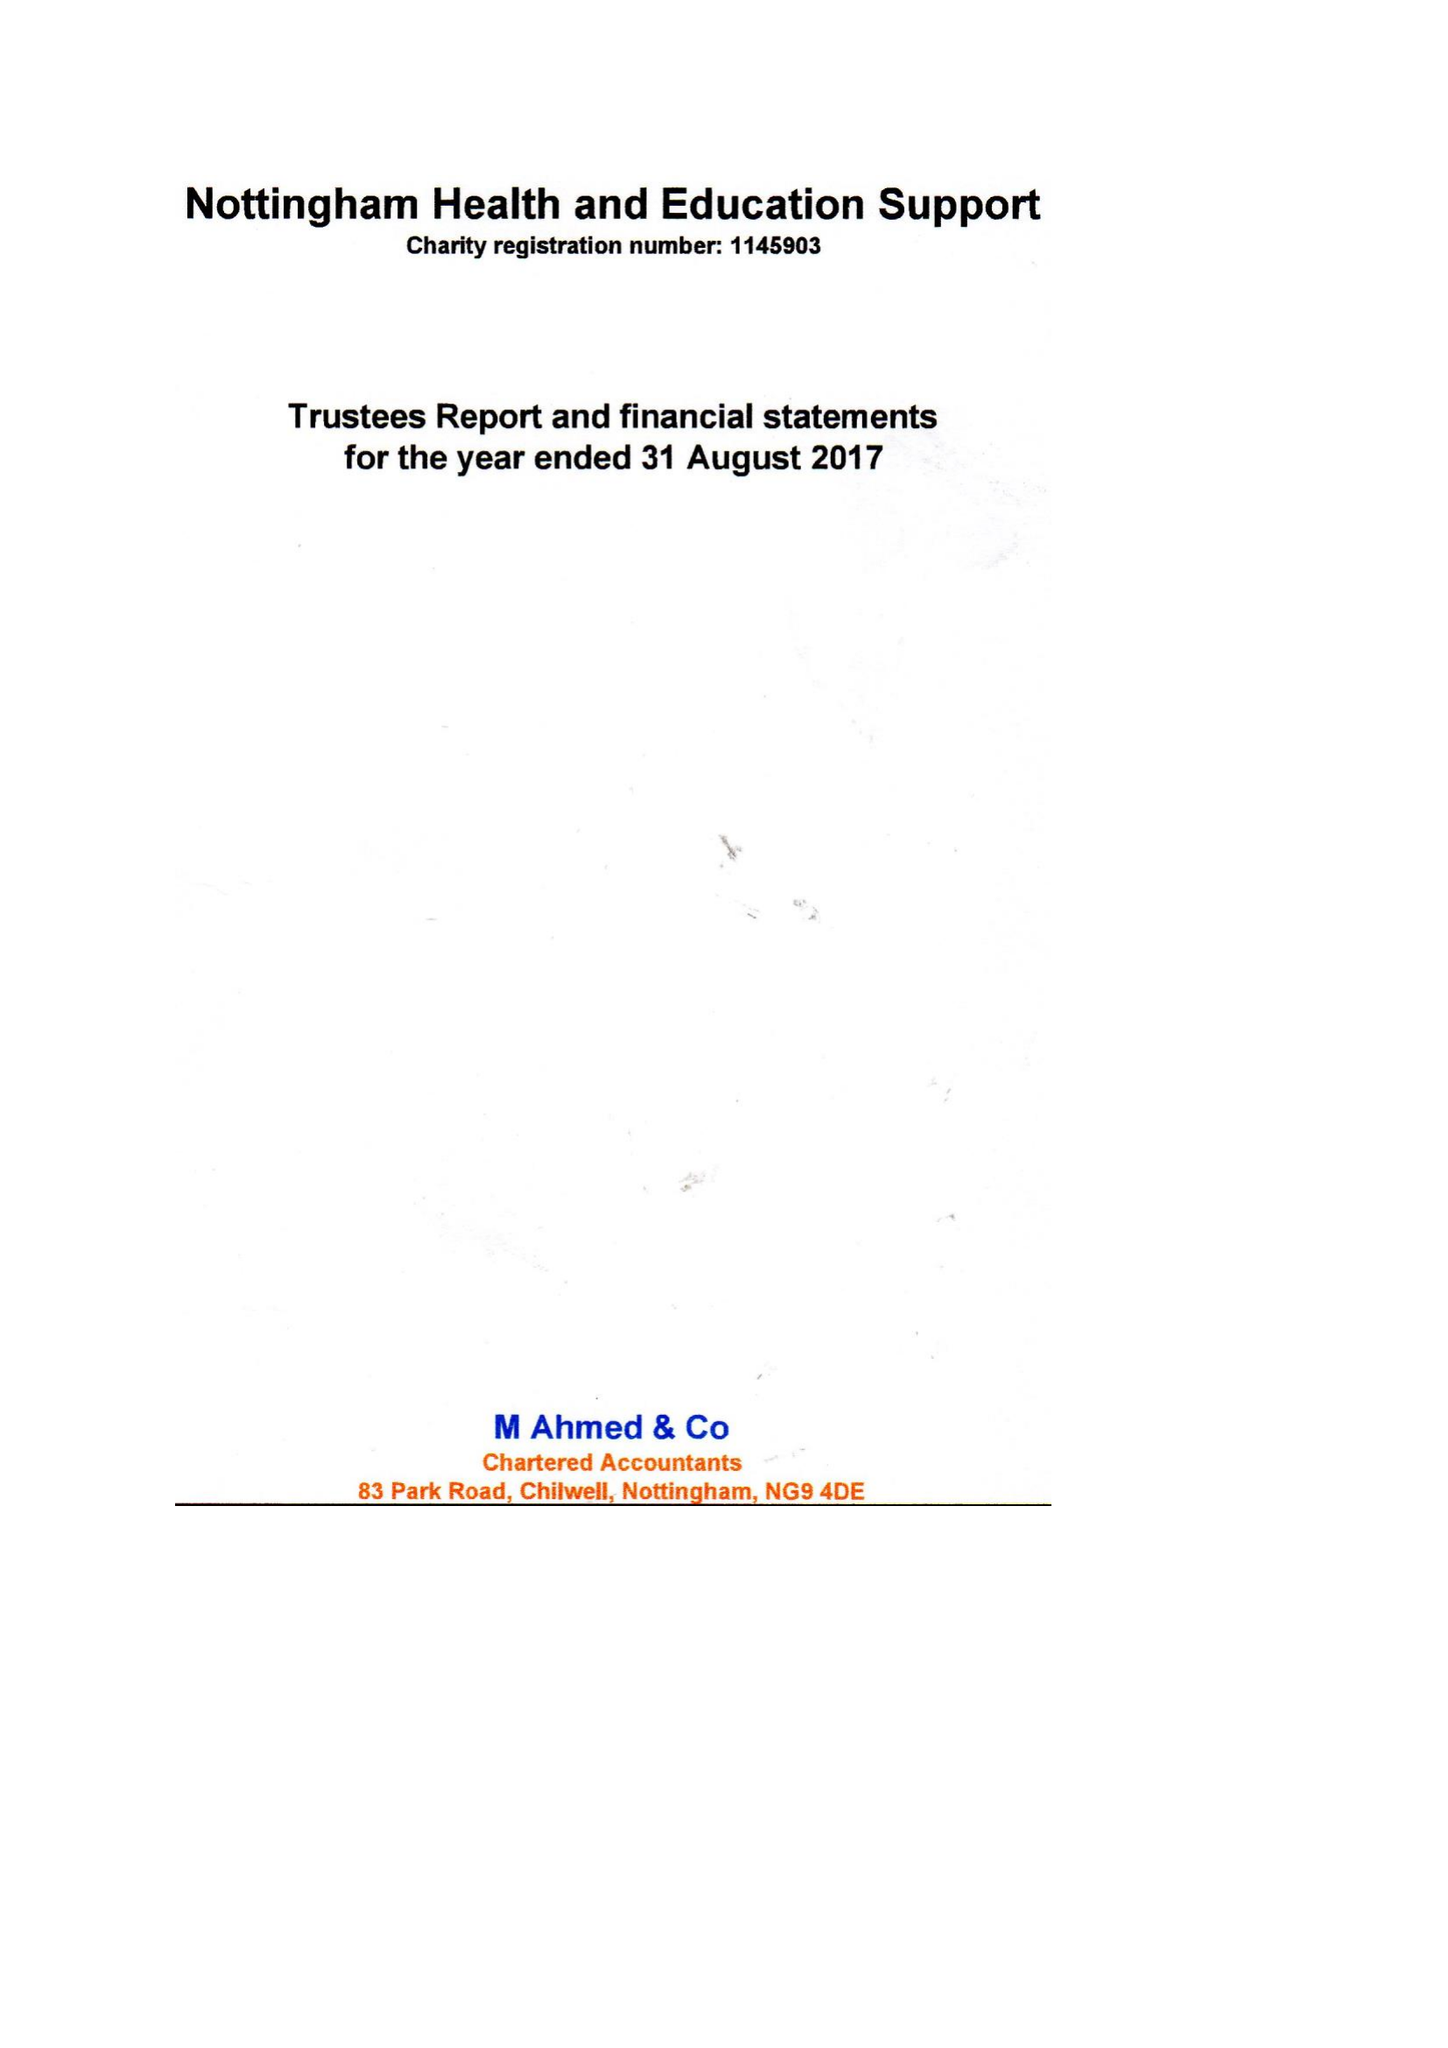What is the value for the address__postcode?
Answer the question using a single word or phrase. NG3 6JX 